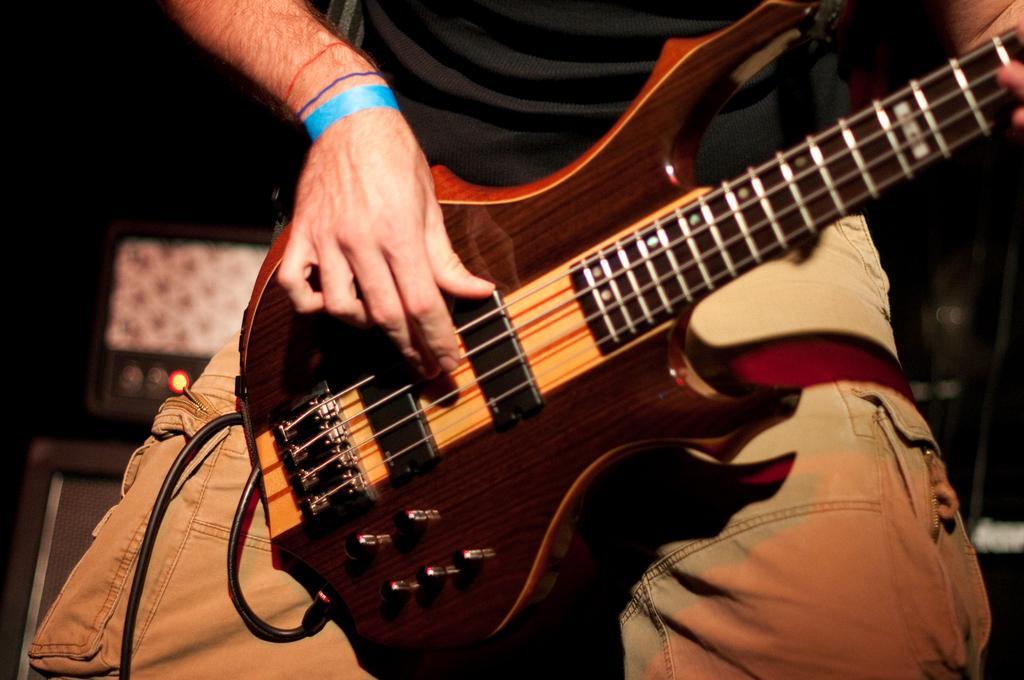Could you give a brief overview of what you see in this image? As we can see in the image there is a man holding guitar. 